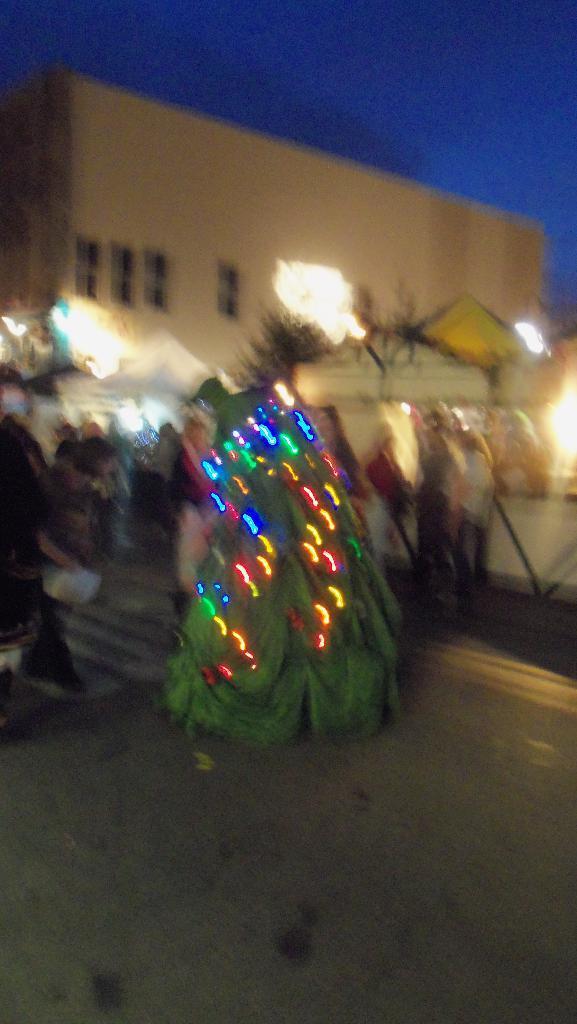Please provide a concise description of this image. This is a blurred image , where there is a tree decorated with lights, group of people, buildings, sky. 